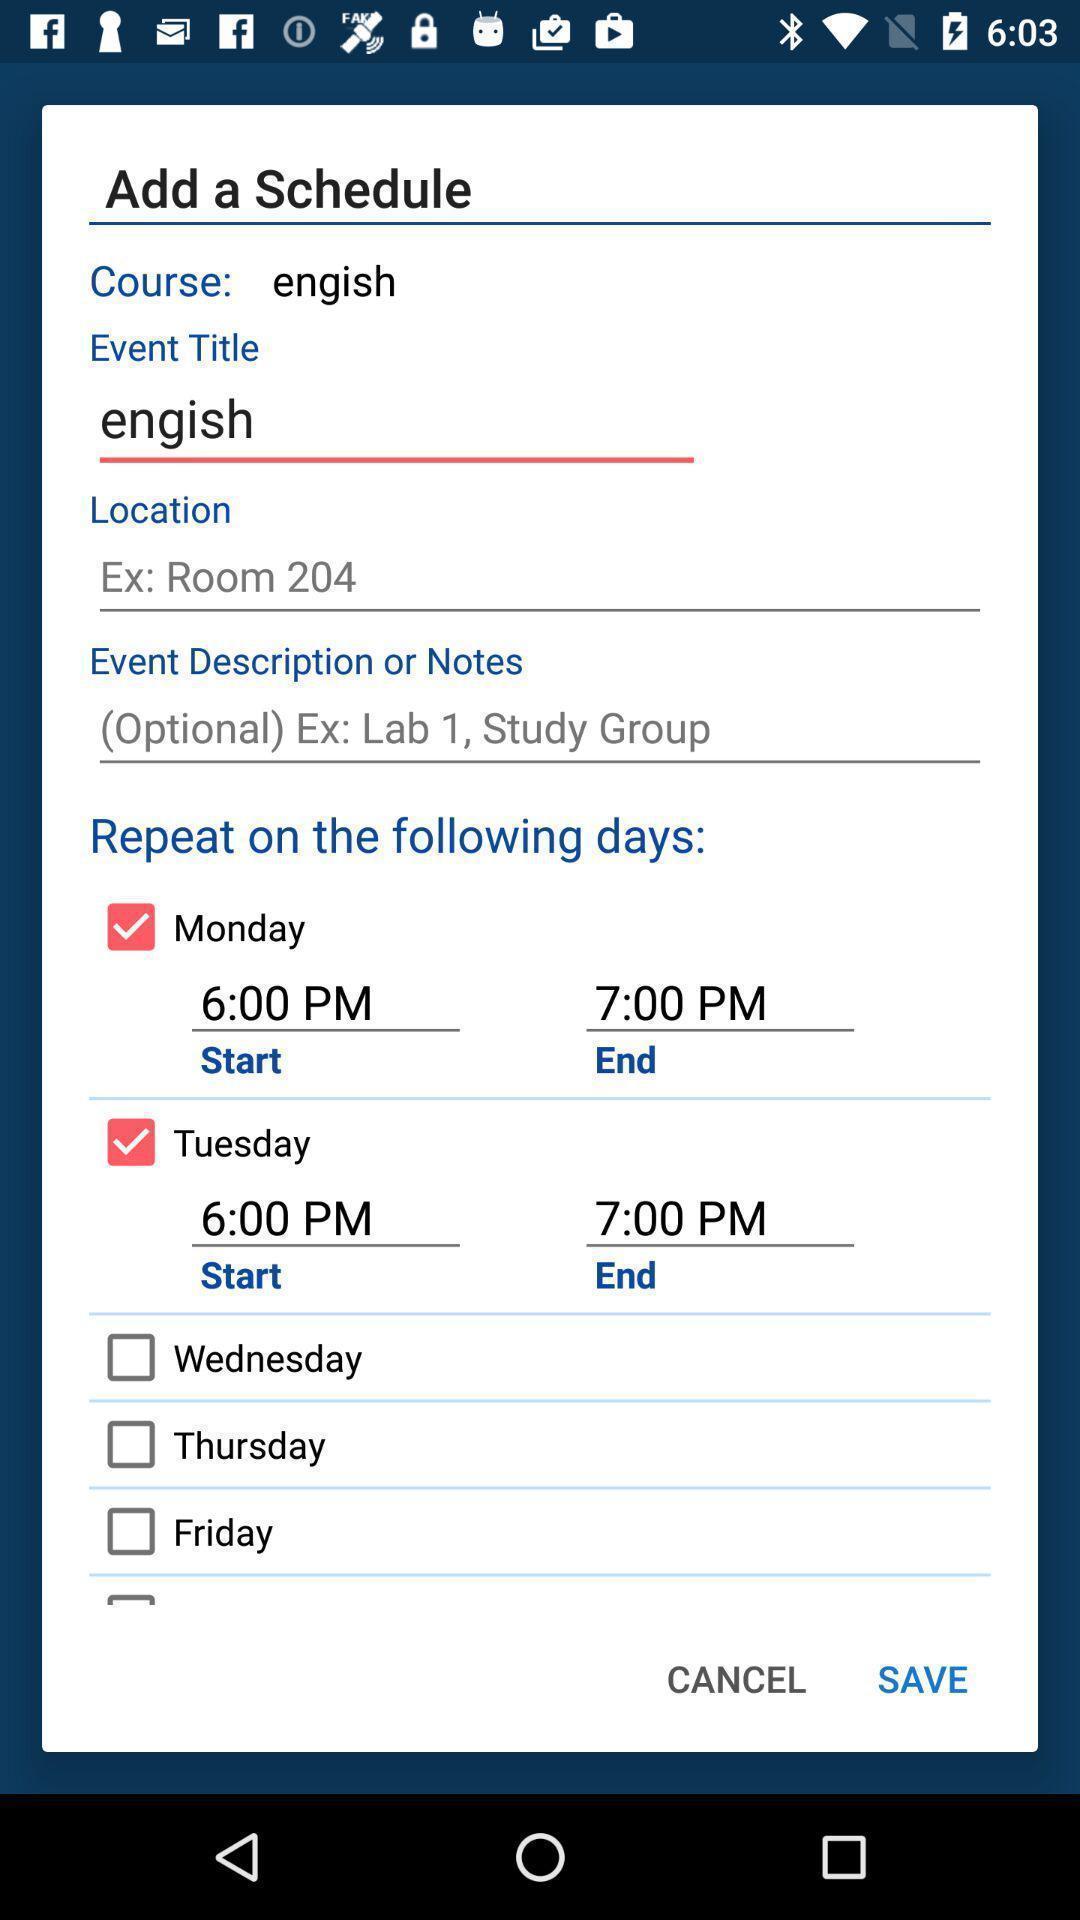Provide a detailed account of this screenshot. Screen shows add schedule details in a learning app. 